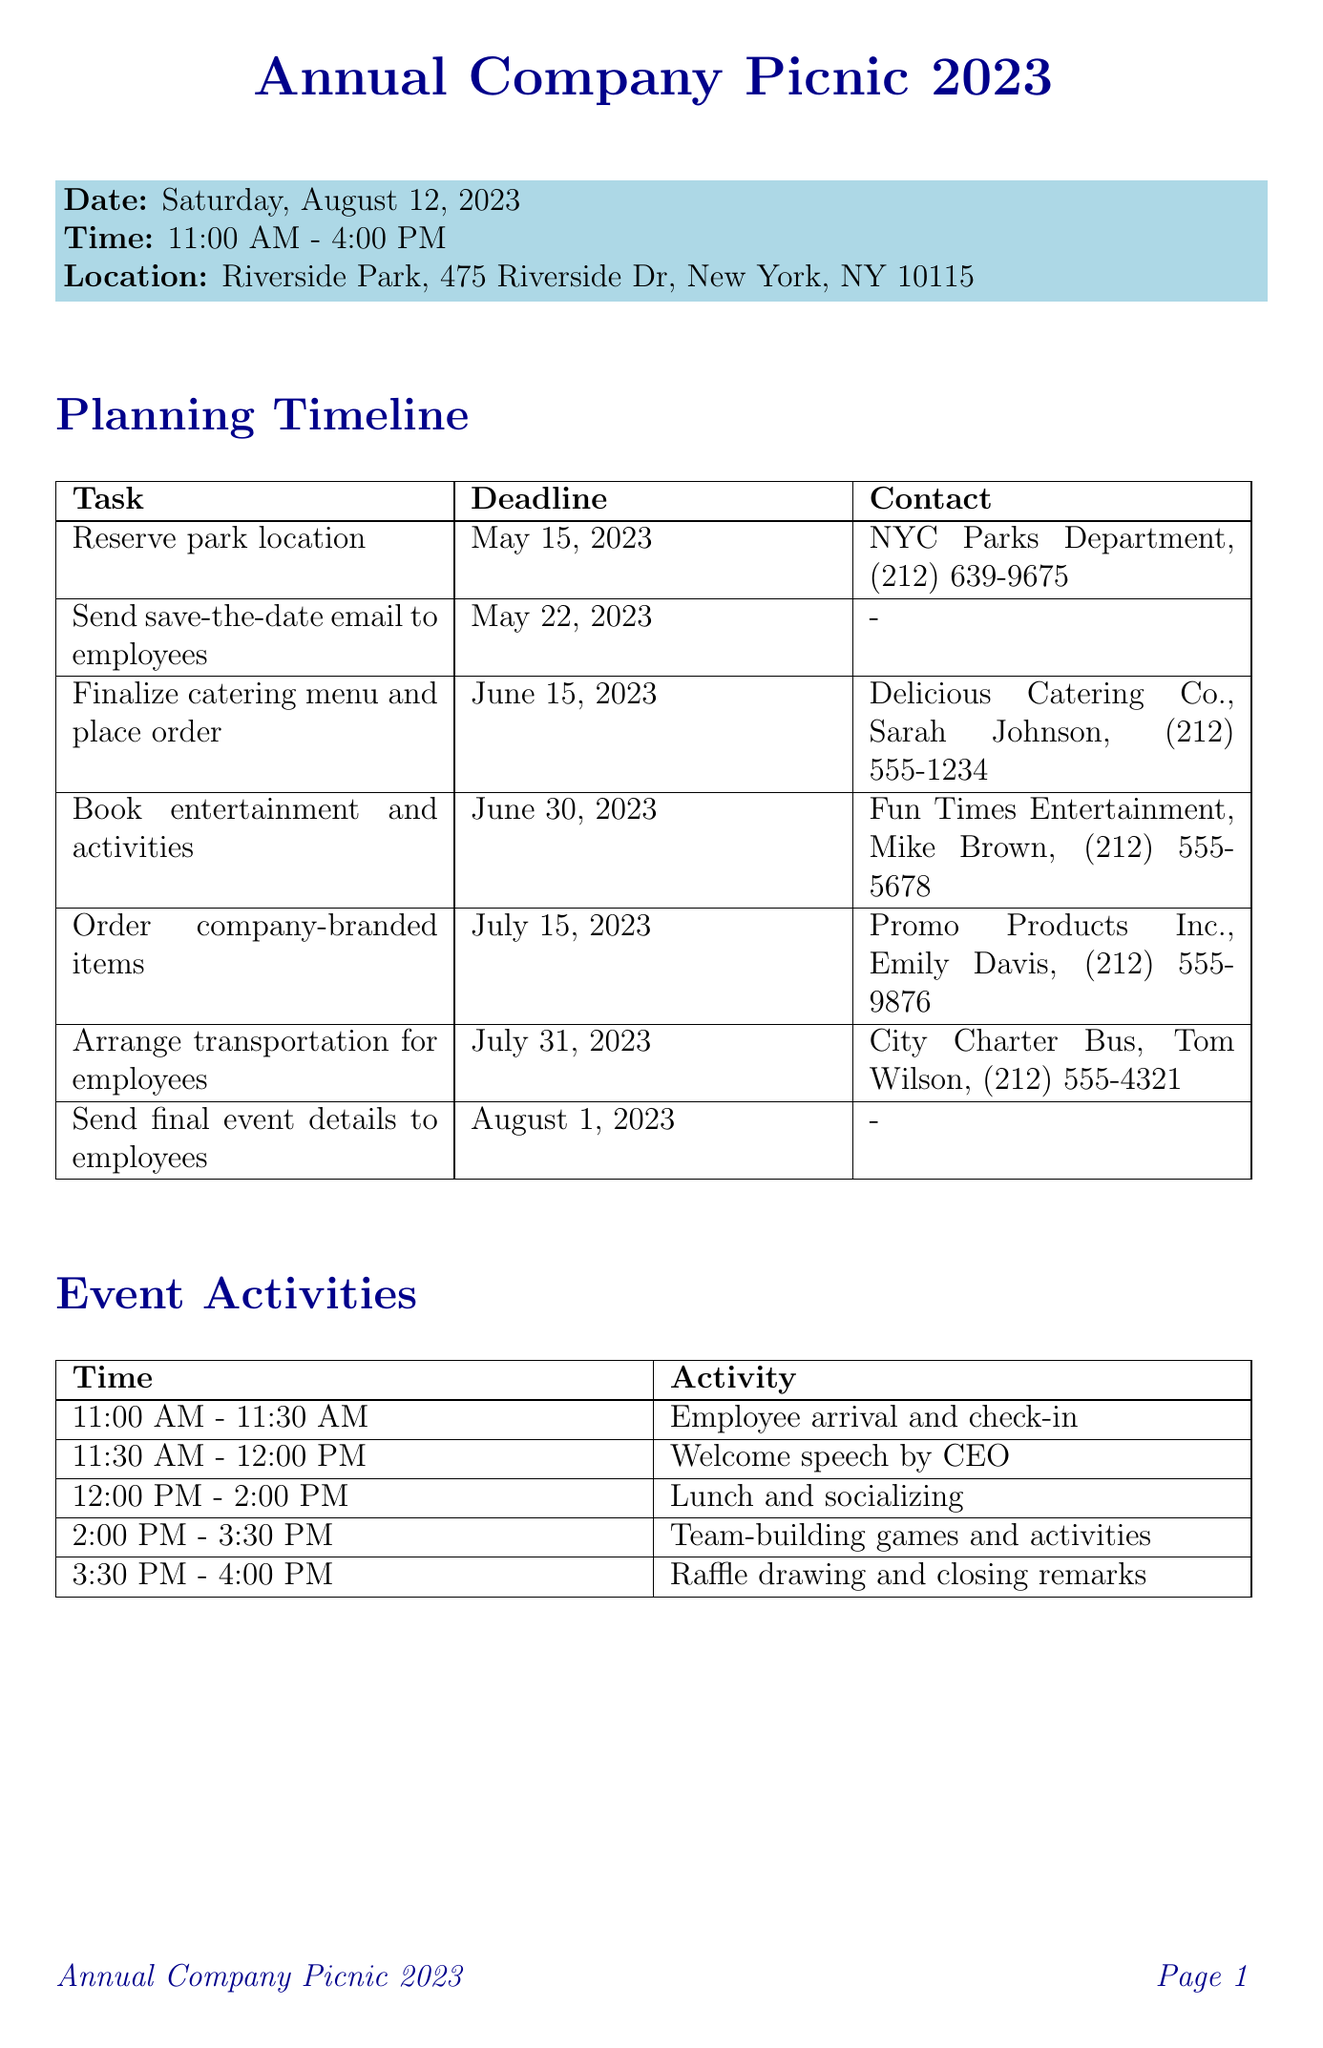What is the date of the picnic? The date of the picnic is specified in the event details section.
Answer: Saturday, August 12, 2023 Who is the contact person for arranging transportation? The contact details for transportation can be found in the planning timeline under transportation arrangements.
Answer: Tom Wilson What time does the event start? This information is listed in the event details section of the document.
Answer: 11:00 AM How much is allocated for catering? The budget breakdown section provides the amount designated for catering services.
Answer: 6000 What task is due on July 15, 2023? The planning timeline lists tasks and their respective deadlines, including this date.
Answer: Order company-branded items What is the total budget for the picnic? The total budget is the sum of all budget categories listed in the budget breakdown section.
Answer: 16000 What activity occurs immediately after employee check-in? The event activities section outlines the schedule of activities during the picnic.
Answer: Welcome speech by CEO What will be collected from employees after the event? The post-event tasks section specifies the follow-up actions to be taken after the event.
Answer: Feedback How many people is the catering budget meant to serve? This information can be derived from the notes in the budget breakdown.
Answer: 200 people 